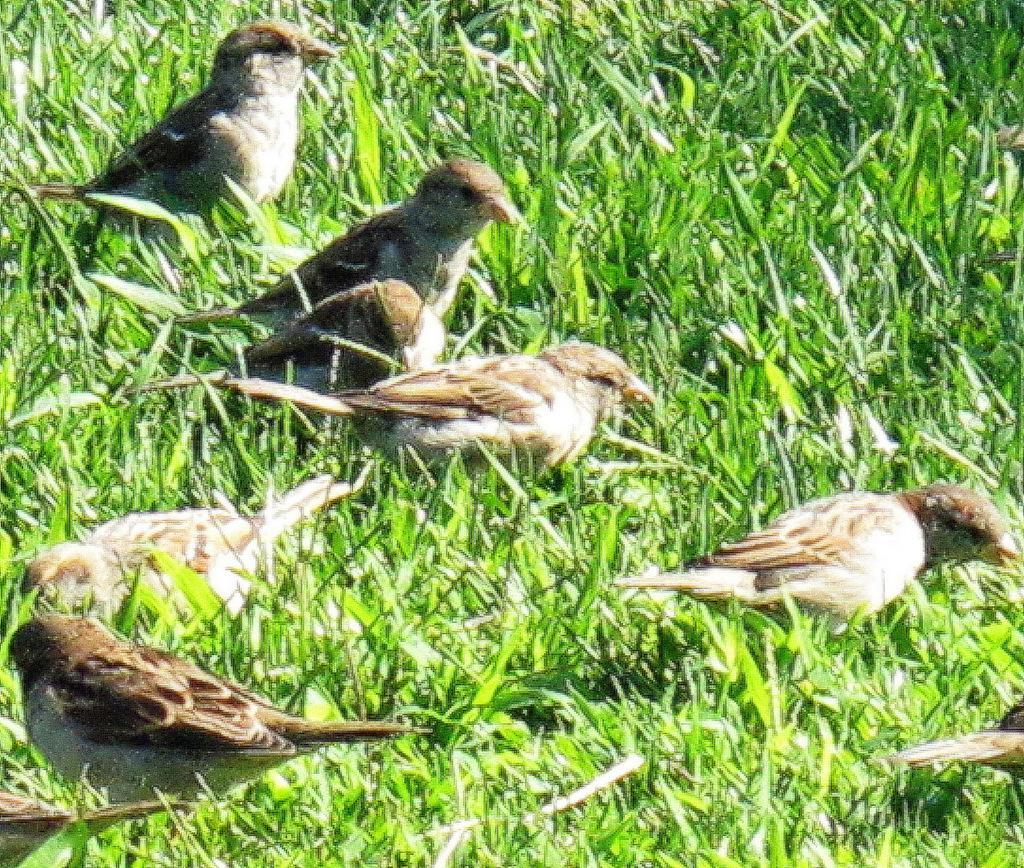What type of animals can be seen in the image? There are birds in the image. Where are the birds located? The birds are on the grass. What type of heart can be seen in the image? There is no heart present in the image; it features birds on the grass. What is the zinc content of the birds in the image? There is no information about the zinc content of the birds in the image, as it is not relevant to the image's content. 